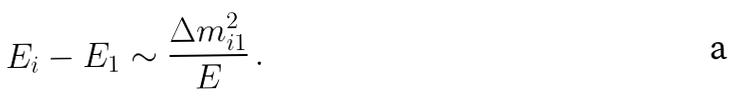Convert formula to latex. <formula><loc_0><loc_0><loc_500><loc_500>E _ { i } - E _ { 1 } \sim \frac { \Delta { m } ^ { 2 } _ { i 1 } } { E } \, .</formula> 